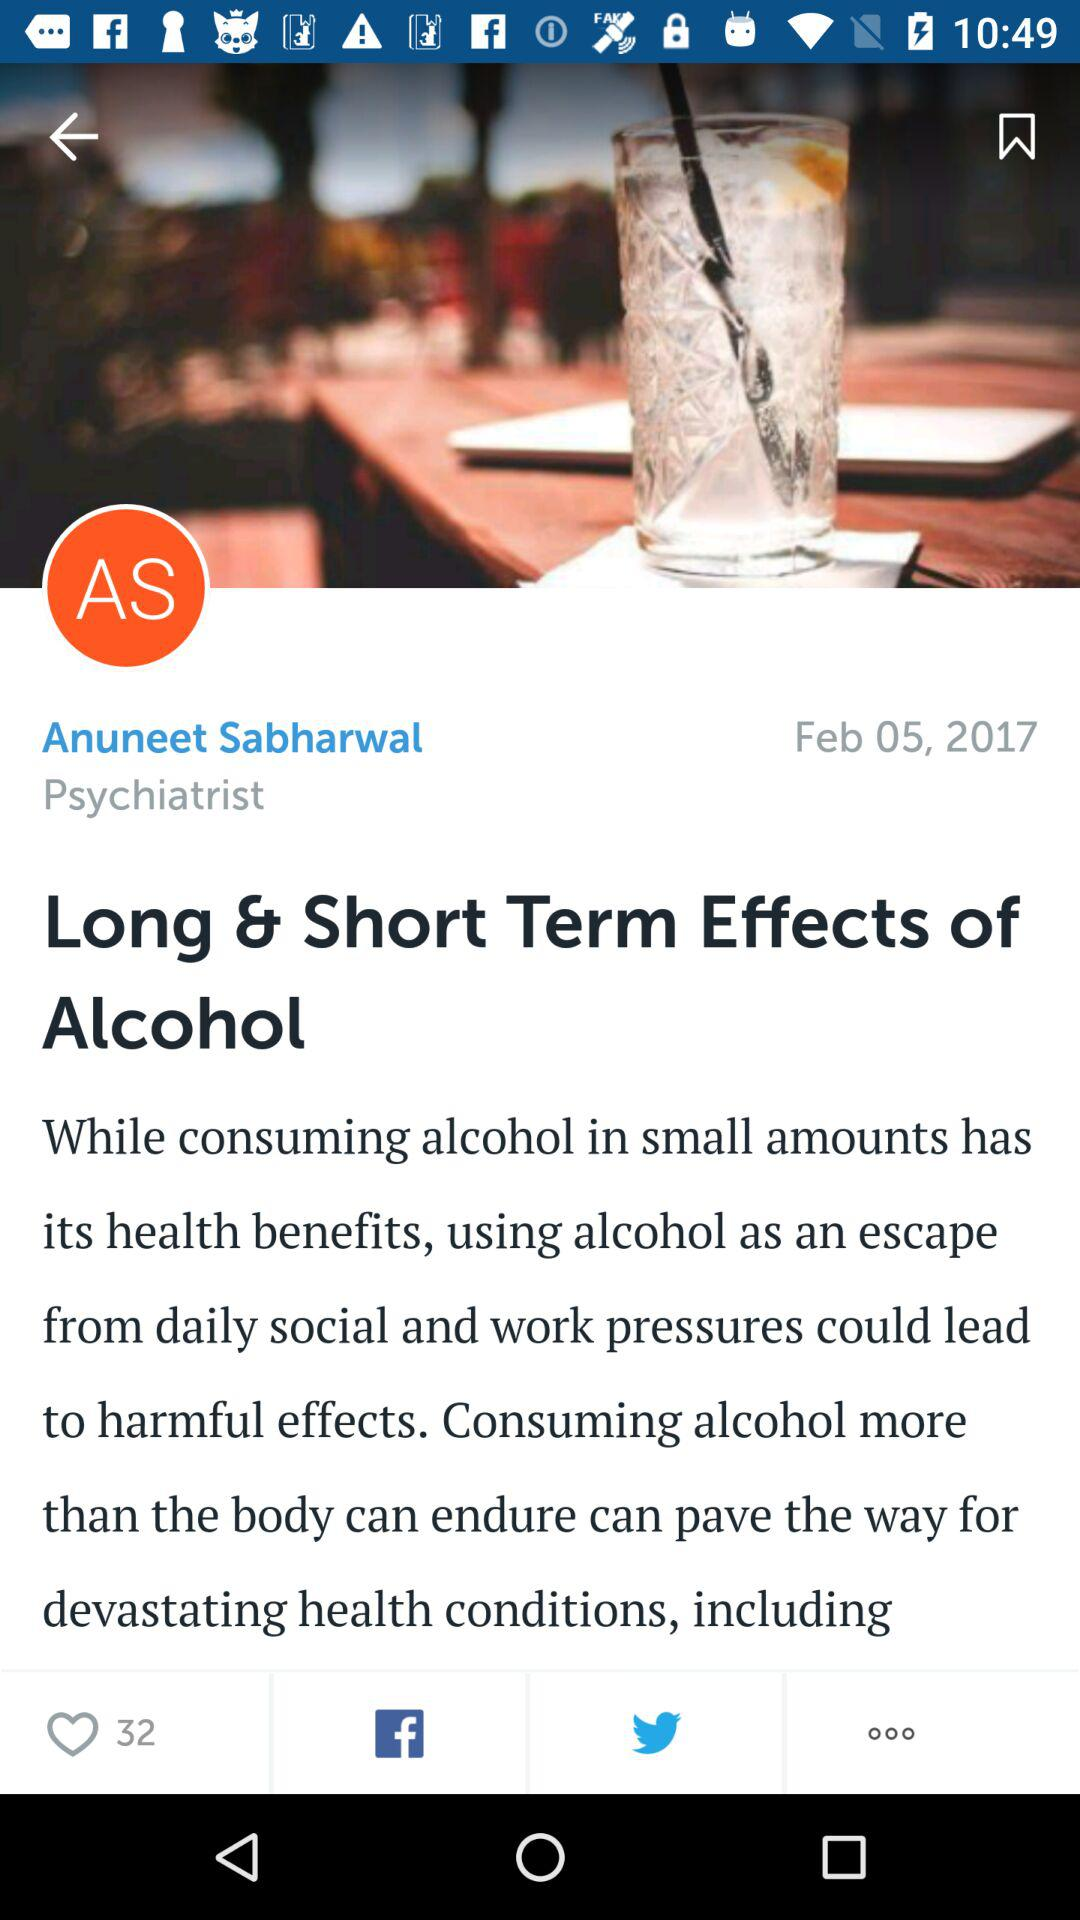What are the given sharing options? The given sharing options are "Facebook" and "Twitter". 